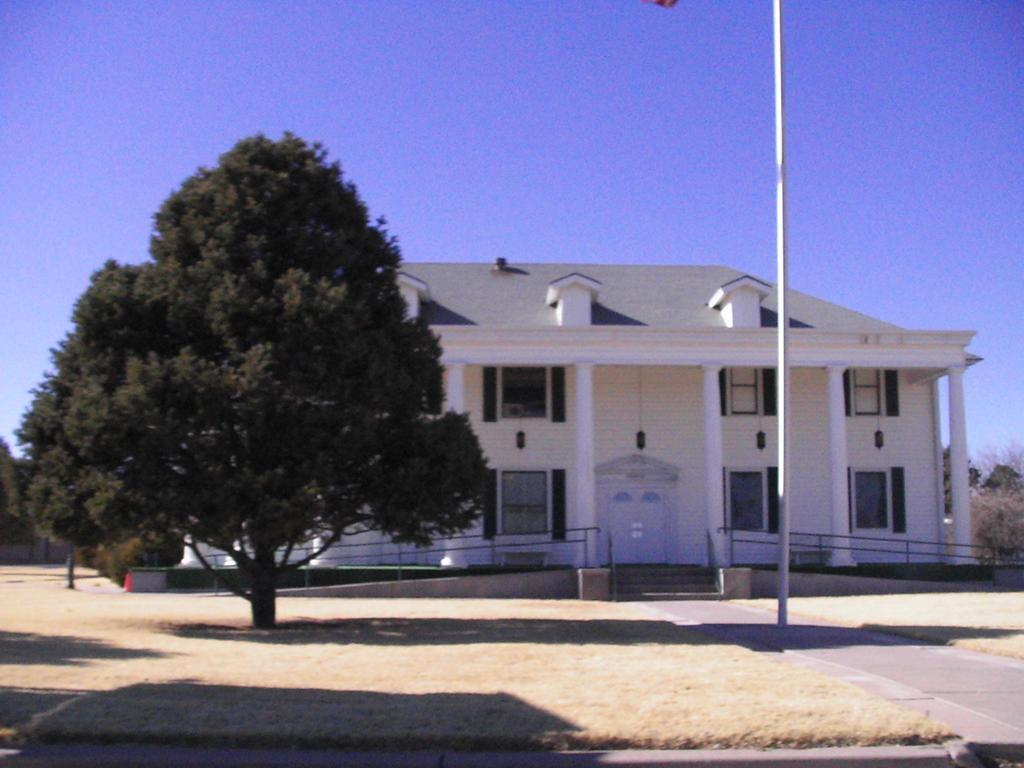What type of surface can be seen in the image? There is a path in the image. What type of vegetation is present in the image? There is grass and trees in the image. What type of structure is visible in the image? There is a building in the image. What type of safety feature is present in the image? There are railings in the image. What type of vertical structure is present in the image? There is a pole in the image. What can be seen in the background of the image? The sky is visible in the background of the image. What type of game is being played in the image? There is no game being played in the image. What type of window is visible in the image? There is no window visible in the image. 